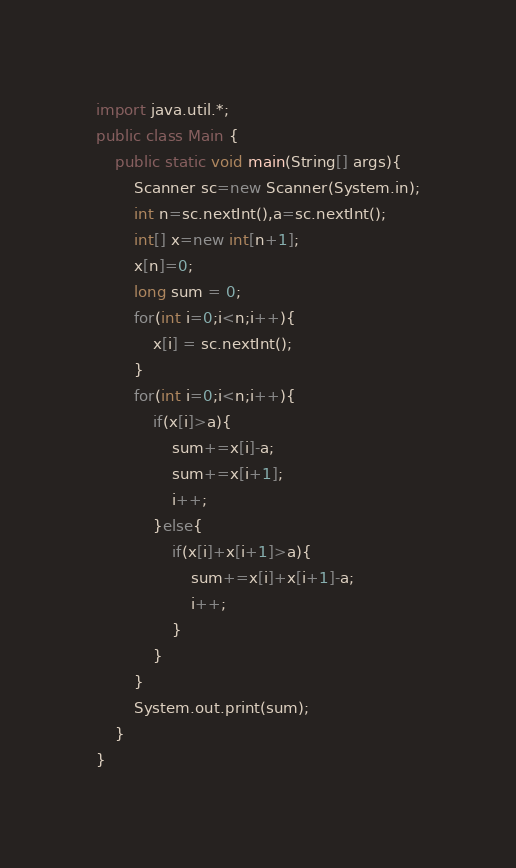Convert code to text. <code><loc_0><loc_0><loc_500><loc_500><_Java_>import java.util.*;
public class Main {
	public static void main(String[] args){
		Scanner sc=new Scanner(System.in);
		int n=sc.nextInt(),a=sc.nextInt();
		int[] x=new int[n+1];
		x[n]=0;
		long sum = 0;
		for(int i=0;i<n;i++){
			x[i] = sc.nextInt();
		}
		for(int i=0;i<n;i++){
			if(x[i]>a){
				sum+=x[i]-a;
				sum+=x[i+1];
				i++;
			}else{
				if(x[i]+x[i+1]>a){
					sum+=x[i]+x[i+1]-a;
					i++;
				}
			}
		}
		System.out.print(sum);
	}
}</code> 